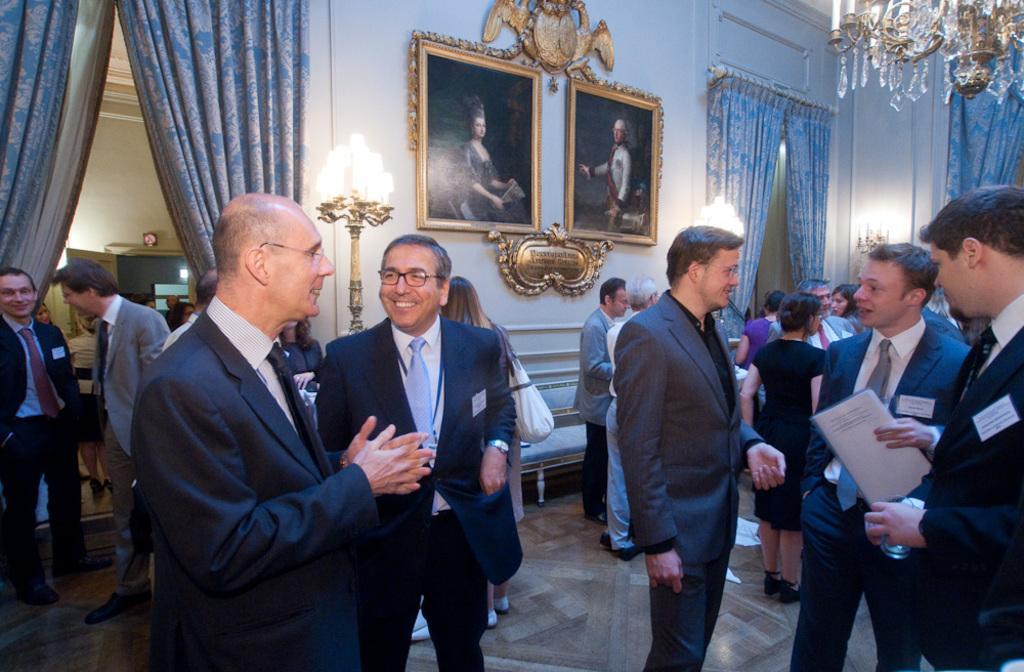Can you describe this image briefly? In this image we can see a group of people standing on the floor. In that a man is holding a paper and the other is holding a glass. On the backside we can see a clock on a wall, some curtains, a door, some candles on the stands, a sofa, a chandelier and some photo frames on a wall. 